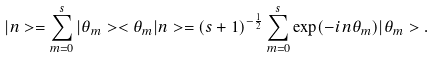<formula> <loc_0><loc_0><loc_500><loc_500>| n > = \sum ^ { s } _ { m = 0 } | \theta _ { m } > < \theta _ { m } | n > = ( s + 1 ) ^ { - \frac { 1 } { 2 } } \sum ^ { s } _ { m = 0 } \exp ( - i n \theta _ { m } ) | \theta _ { m } > .</formula> 